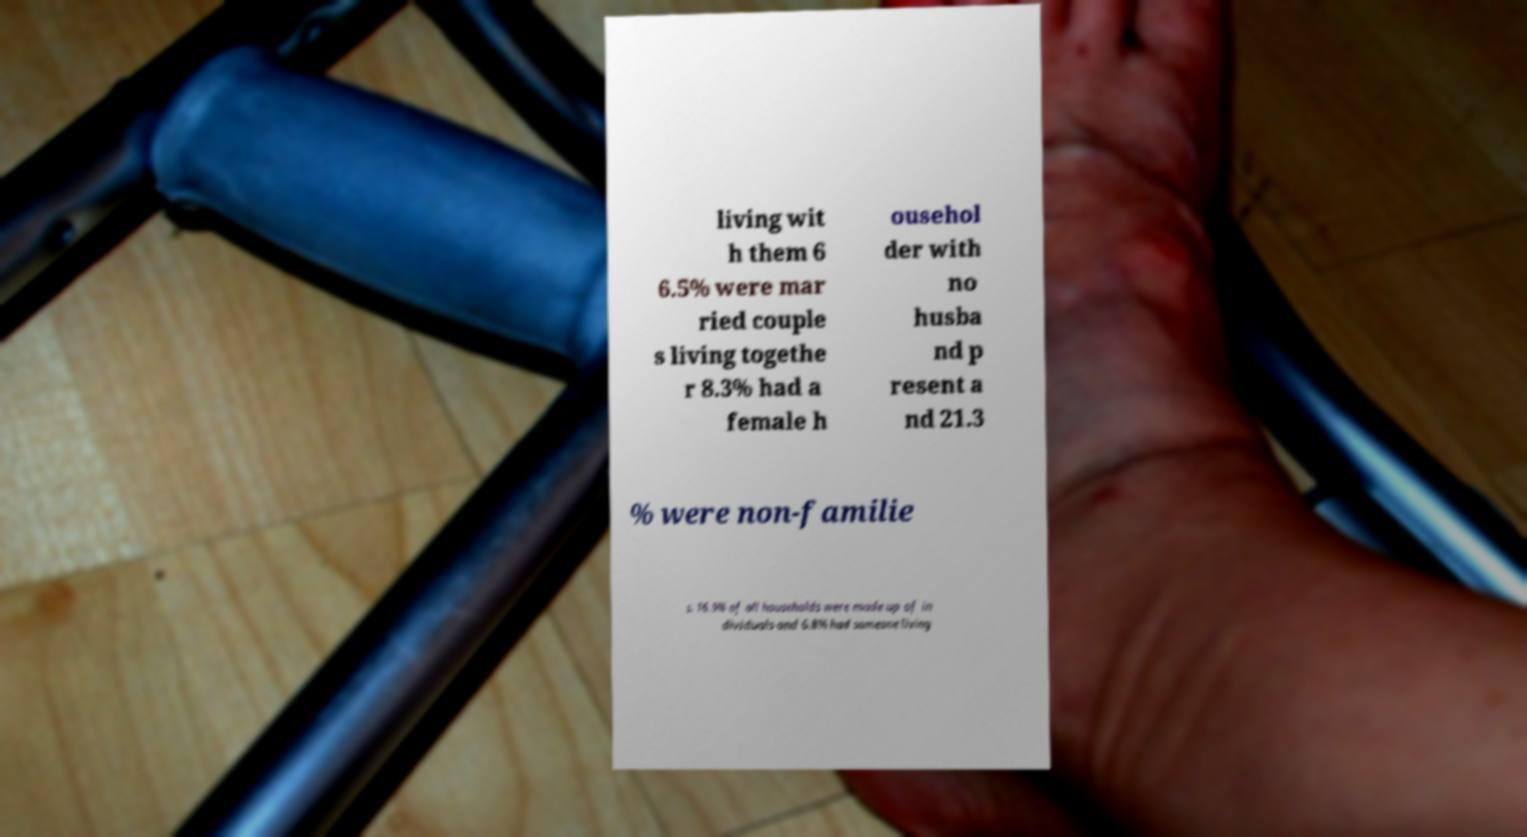Please identify and transcribe the text found in this image. living wit h them 6 6.5% were mar ried couple s living togethe r 8.3% had a female h ousehol der with no husba nd p resent a nd 21.3 % were non-familie s. 16.9% of all households were made up of in dividuals and 6.8% had someone living 